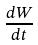Convert formula to latex. <formula><loc_0><loc_0><loc_500><loc_500>\frac { d W } { d t }</formula> 